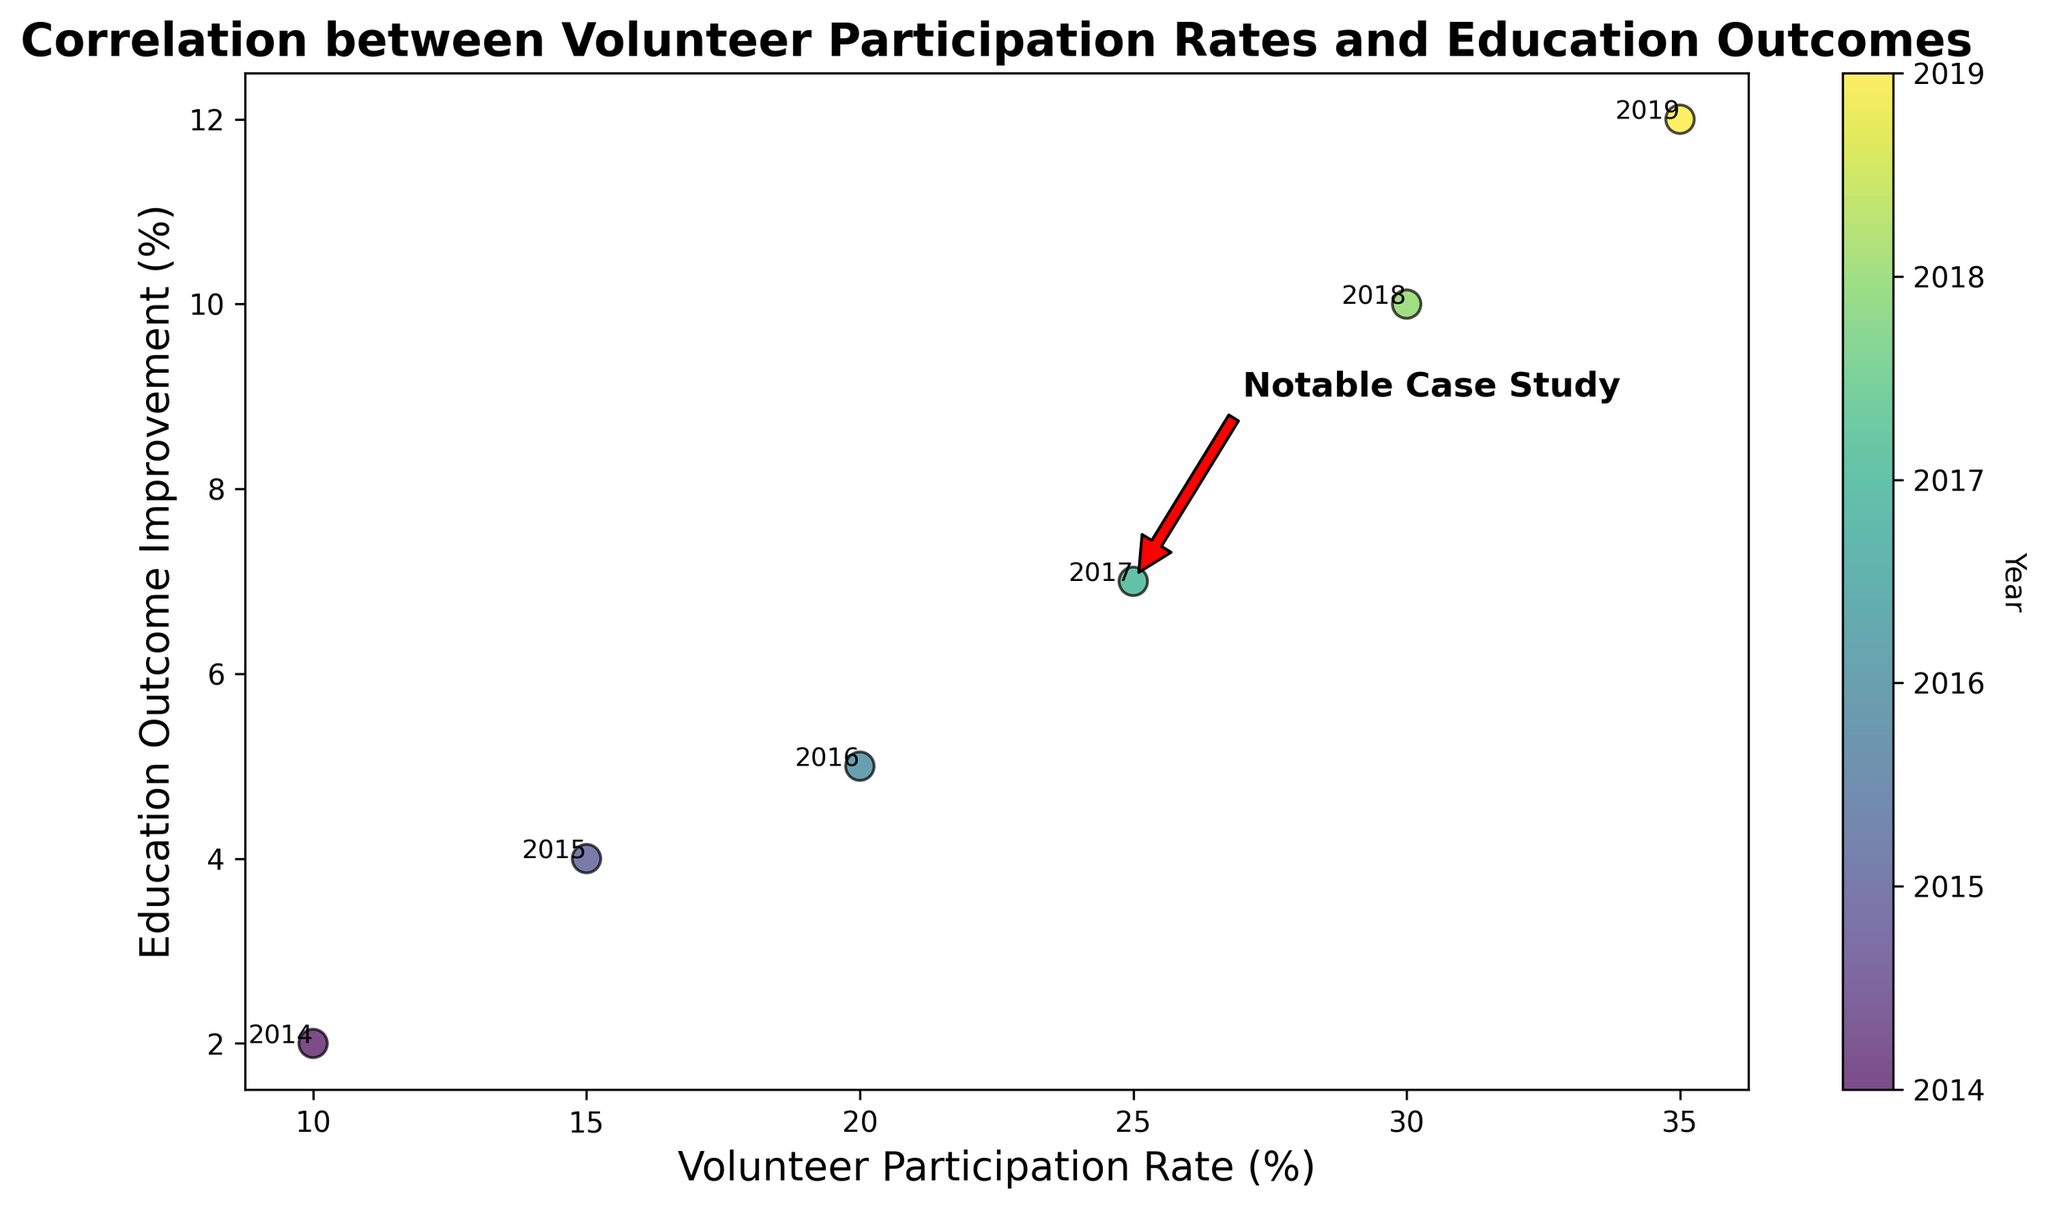what's the average volunteer participation rate over the years? To find the average, sum the participation rates for all years and divide by the number of years. (10 + 15 + 20 + 25 + 30 + 35) / 6 = 135 / 6 = 22.5
Answer: 22.5 which year had the highest improvement in education outcomes? By scanning the y-axis values, 2019 has the highest improvement in education outcomes with a value of 12.
Answer: 2019 how much did the education outcome improvement increase from 2014 to 2017? Subtract the 2014 improvement from the 2017 improvement: 7 - 2 = 5.
Answer: 5 what is the correlation trend between volunteer participation rates and education outcomes? Observe the scatter plot points; as the volunteer participation rate increases, the education outcome improvement also increases, indicating a positive correlation.
Answer: positive which year corresponds to the 'Notable Case Study' annotation? The 'Notable Case Study' annotation points to the year 2017 on the scatter plot.
Answer: 2017 comparing 2016 and 2018, which year had a higher volunteer participation rate? By examining the x-axis, 2018 had a higher volunteer participation rate (30) compared to 2016 (20).
Answer: 2018 what color represents the year 2016? Because the years are color-coded on the color bar, the year 2016 is represented by a lighter shade of the gradient compared to the earlier years.
Answer: lighter shade by how much did the education outcome improvement increase from 2015 to 2018? Subtract the 2015 improvement from the 2018 improvement: 10 - 4 = 6.
Answer: 6 which two years have the closest volunteer participation rates? The years 2015 and 2016 have the closest volunteer participation rates (15 and 20), with a difference of only 5.
Answer: 2015 and 2016 considering 2014 and 2019, what is the difference in education outcome improvement? Subtract the 2014 improvement from the 2019 improvement: 12 - 2 = 10.
Answer: 10 